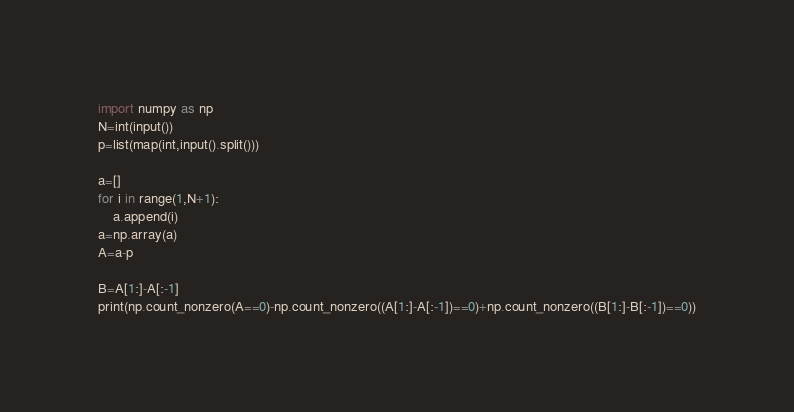<code> <loc_0><loc_0><loc_500><loc_500><_Python_>import numpy as np
N=int(input())
p=list(map(int,input().split()))

a=[]
for i in range(1,N+1):
    a.append(i)
a=np.array(a)
A=a-p

B=A[1:]-A[:-1]
print(np.count_nonzero(A==0)-np.count_nonzero((A[1:]-A[:-1])==0)+np.count_nonzero((B[1:]-B[:-1])==0))</code> 